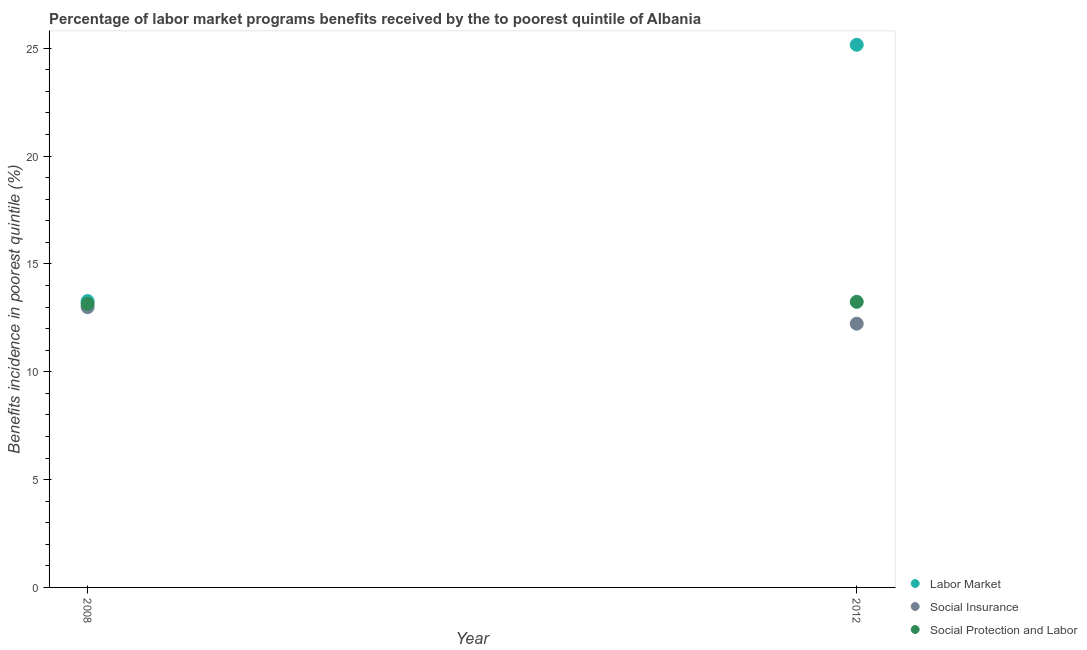How many different coloured dotlines are there?
Offer a very short reply. 3. Is the number of dotlines equal to the number of legend labels?
Keep it short and to the point. Yes. What is the percentage of benefits received due to social insurance programs in 2008?
Provide a short and direct response. 13. Across all years, what is the maximum percentage of benefits received due to labor market programs?
Ensure brevity in your answer.  25.16. Across all years, what is the minimum percentage of benefits received due to social insurance programs?
Offer a very short reply. 12.23. In which year was the percentage of benefits received due to social insurance programs minimum?
Offer a very short reply. 2012. What is the total percentage of benefits received due to labor market programs in the graph?
Provide a short and direct response. 38.44. What is the difference between the percentage of benefits received due to social protection programs in 2008 and that in 2012?
Give a very brief answer. -0.09. What is the difference between the percentage of benefits received due to social insurance programs in 2012 and the percentage of benefits received due to labor market programs in 2008?
Ensure brevity in your answer.  -1.05. What is the average percentage of benefits received due to labor market programs per year?
Ensure brevity in your answer.  19.22. In the year 2012, what is the difference between the percentage of benefits received due to labor market programs and percentage of benefits received due to social insurance programs?
Ensure brevity in your answer.  12.93. What is the ratio of the percentage of benefits received due to social protection programs in 2008 to that in 2012?
Your response must be concise. 0.99. Is the percentage of benefits received due to social protection programs in 2008 less than that in 2012?
Your answer should be compact. Yes. In how many years, is the percentage of benefits received due to labor market programs greater than the average percentage of benefits received due to labor market programs taken over all years?
Keep it short and to the point. 1. Is it the case that in every year, the sum of the percentage of benefits received due to labor market programs and percentage of benefits received due to social insurance programs is greater than the percentage of benefits received due to social protection programs?
Offer a terse response. Yes. Does the percentage of benefits received due to social insurance programs monotonically increase over the years?
Provide a short and direct response. No. Is the percentage of benefits received due to labor market programs strictly greater than the percentage of benefits received due to social insurance programs over the years?
Offer a terse response. Yes. How many dotlines are there?
Provide a succinct answer. 3. Are the values on the major ticks of Y-axis written in scientific E-notation?
Provide a succinct answer. No. Does the graph contain any zero values?
Provide a succinct answer. No. Does the graph contain grids?
Keep it short and to the point. No. Where does the legend appear in the graph?
Keep it short and to the point. Bottom right. How many legend labels are there?
Give a very brief answer. 3. How are the legend labels stacked?
Offer a terse response. Vertical. What is the title of the graph?
Your answer should be very brief. Percentage of labor market programs benefits received by the to poorest quintile of Albania. Does "Domestic" appear as one of the legend labels in the graph?
Offer a terse response. No. What is the label or title of the X-axis?
Keep it short and to the point. Year. What is the label or title of the Y-axis?
Provide a short and direct response. Benefits incidence in poorest quintile (%). What is the Benefits incidence in poorest quintile (%) in Labor Market in 2008?
Make the answer very short. 13.28. What is the Benefits incidence in poorest quintile (%) of Social Insurance in 2008?
Your response must be concise. 13. What is the Benefits incidence in poorest quintile (%) in Social Protection and Labor in 2008?
Provide a succinct answer. 13.15. What is the Benefits incidence in poorest quintile (%) of Labor Market in 2012?
Provide a succinct answer. 25.16. What is the Benefits incidence in poorest quintile (%) in Social Insurance in 2012?
Provide a short and direct response. 12.23. What is the Benefits incidence in poorest quintile (%) of Social Protection and Labor in 2012?
Offer a terse response. 13.24. Across all years, what is the maximum Benefits incidence in poorest quintile (%) of Labor Market?
Your answer should be very brief. 25.16. Across all years, what is the maximum Benefits incidence in poorest quintile (%) of Social Insurance?
Provide a succinct answer. 13. Across all years, what is the maximum Benefits incidence in poorest quintile (%) in Social Protection and Labor?
Your response must be concise. 13.24. Across all years, what is the minimum Benefits incidence in poorest quintile (%) in Labor Market?
Your answer should be very brief. 13.28. Across all years, what is the minimum Benefits incidence in poorest quintile (%) in Social Insurance?
Your response must be concise. 12.23. Across all years, what is the minimum Benefits incidence in poorest quintile (%) of Social Protection and Labor?
Your answer should be compact. 13.15. What is the total Benefits incidence in poorest quintile (%) of Labor Market in the graph?
Offer a terse response. 38.44. What is the total Benefits incidence in poorest quintile (%) of Social Insurance in the graph?
Offer a very short reply. 25.22. What is the total Benefits incidence in poorest quintile (%) in Social Protection and Labor in the graph?
Keep it short and to the point. 26.39. What is the difference between the Benefits incidence in poorest quintile (%) of Labor Market in 2008 and that in 2012?
Give a very brief answer. -11.88. What is the difference between the Benefits incidence in poorest quintile (%) of Social Insurance in 2008 and that in 2012?
Your answer should be very brief. 0.77. What is the difference between the Benefits incidence in poorest quintile (%) of Social Protection and Labor in 2008 and that in 2012?
Provide a succinct answer. -0.09. What is the difference between the Benefits incidence in poorest quintile (%) of Labor Market in 2008 and the Benefits incidence in poorest quintile (%) of Social Insurance in 2012?
Your answer should be compact. 1.05. What is the difference between the Benefits incidence in poorest quintile (%) of Labor Market in 2008 and the Benefits incidence in poorest quintile (%) of Social Protection and Labor in 2012?
Your answer should be compact. 0.04. What is the difference between the Benefits incidence in poorest quintile (%) in Social Insurance in 2008 and the Benefits incidence in poorest quintile (%) in Social Protection and Labor in 2012?
Provide a succinct answer. -0.24. What is the average Benefits incidence in poorest quintile (%) in Labor Market per year?
Offer a very short reply. 19.22. What is the average Benefits incidence in poorest quintile (%) of Social Insurance per year?
Offer a very short reply. 12.61. What is the average Benefits incidence in poorest quintile (%) of Social Protection and Labor per year?
Your response must be concise. 13.2. In the year 2008, what is the difference between the Benefits incidence in poorest quintile (%) of Labor Market and Benefits incidence in poorest quintile (%) of Social Insurance?
Your answer should be very brief. 0.28. In the year 2008, what is the difference between the Benefits incidence in poorest quintile (%) in Labor Market and Benefits incidence in poorest quintile (%) in Social Protection and Labor?
Provide a short and direct response. 0.13. In the year 2008, what is the difference between the Benefits incidence in poorest quintile (%) of Social Insurance and Benefits incidence in poorest quintile (%) of Social Protection and Labor?
Your answer should be very brief. -0.15. In the year 2012, what is the difference between the Benefits incidence in poorest quintile (%) in Labor Market and Benefits incidence in poorest quintile (%) in Social Insurance?
Offer a very short reply. 12.93. In the year 2012, what is the difference between the Benefits incidence in poorest quintile (%) of Labor Market and Benefits incidence in poorest quintile (%) of Social Protection and Labor?
Offer a very short reply. 11.92. In the year 2012, what is the difference between the Benefits incidence in poorest quintile (%) in Social Insurance and Benefits incidence in poorest quintile (%) in Social Protection and Labor?
Give a very brief answer. -1.01. What is the ratio of the Benefits incidence in poorest quintile (%) of Labor Market in 2008 to that in 2012?
Your answer should be compact. 0.53. What is the ratio of the Benefits incidence in poorest quintile (%) in Social Insurance in 2008 to that in 2012?
Provide a succinct answer. 1.06. What is the difference between the highest and the second highest Benefits incidence in poorest quintile (%) in Labor Market?
Offer a very short reply. 11.88. What is the difference between the highest and the second highest Benefits incidence in poorest quintile (%) of Social Insurance?
Give a very brief answer. 0.77. What is the difference between the highest and the second highest Benefits incidence in poorest quintile (%) in Social Protection and Labor?
Provide a short and direct response. 0.09. What is the difference between the highest and the lowest Benefits incidence in poorest quintile (%) of Labor Market?
Offer a terse response. 11.88. What is the difference between the highest and the lowest Benefits incidence in poorest quintile (%) of Social Insurance?
Your response must be concise. 0.77. What is the difference between the highest and the lowest Benefits incidence in poorest quintile (%) in Social Protection and Labor?
Give a very brief answer. 0.09. 